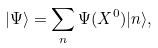Convert formula to latex. <formula><loc_0><loc_0><loc_500><loc_500>| \Psi \rangle = \sum _ { n } \Psi ( X ^ { 0 } ) | n \rangle ,</formula> 